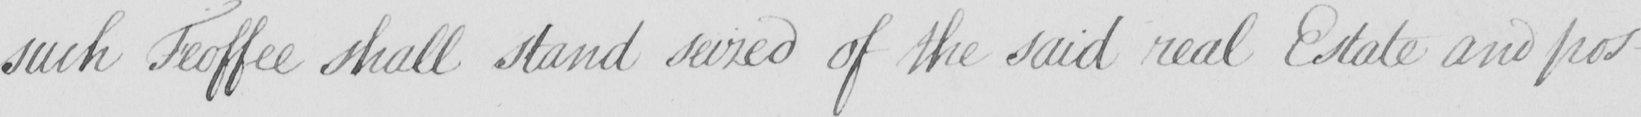Can you read and transcribe this handwriting? such Feoffee shall stand seized of the said real Estate and pos- 